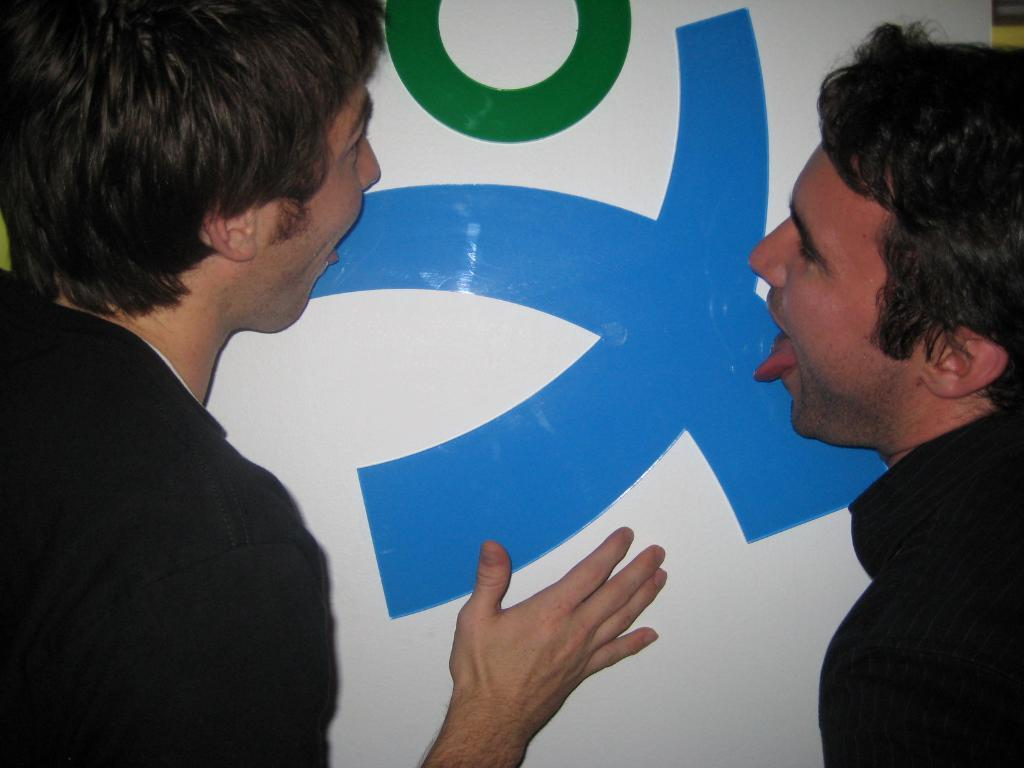How many people are in the image? There are two men in the image. What is the board with letters used for in the image? The purpose of the board with letters is not explicitly stated in the facts, but it appears to be a tool for communication or gameplay. What type of bells can be heard ringing in the image? There are no bells present in the image, and therefore no sound can be heard. 